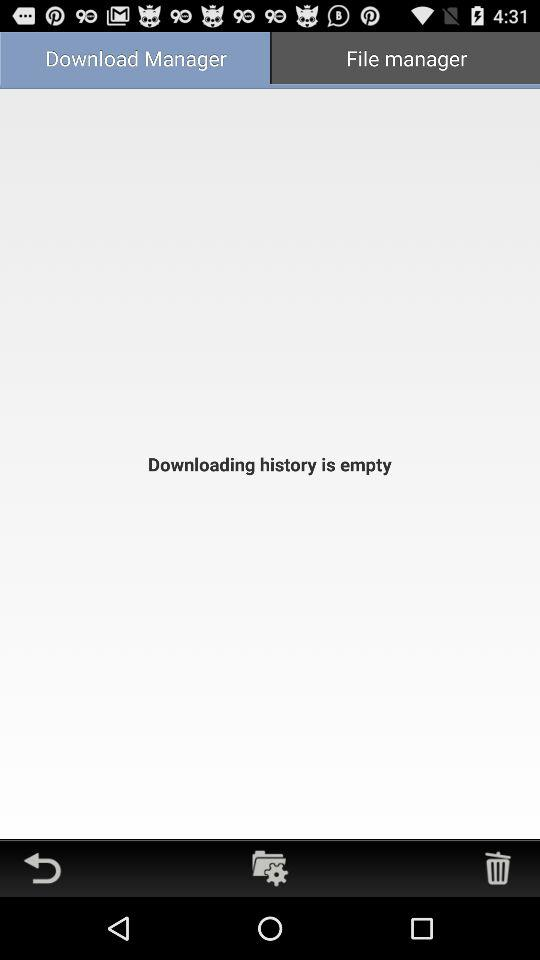Is there any download history? The download history is empty. 